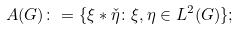Convert formula to latex. <formula><loc_0><loc_0><loc_500><loc_500>A ( G ) \colon = \{ \xi \ast \check { \eta } \colon \xi , \eta \in L ^ { 2 } ( G ) \} ;</formula> 